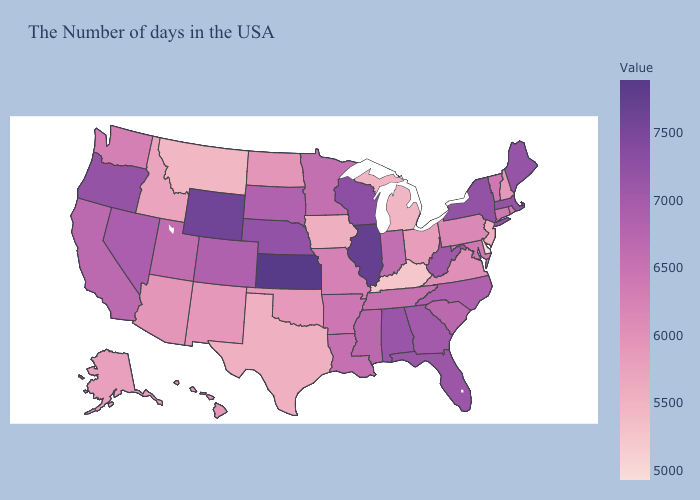Does the map have missing data?
Keep it brief. No. Which states have the lowest value in the USA?
Answer briefly. Delaware. Which states have the lowest value in the USA?
Answer briefly. Delaware. Does Delaware have the lowest value in the South?
Be succinct. Yes. Among the states that border Idaho , which have the highest value?
Short answer required. Wyoming. 